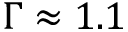Convert formula to latex. <formula><loc_0><loc_0><loc_500><loc_500>\Gamma \approx 1 . 1</formula> 